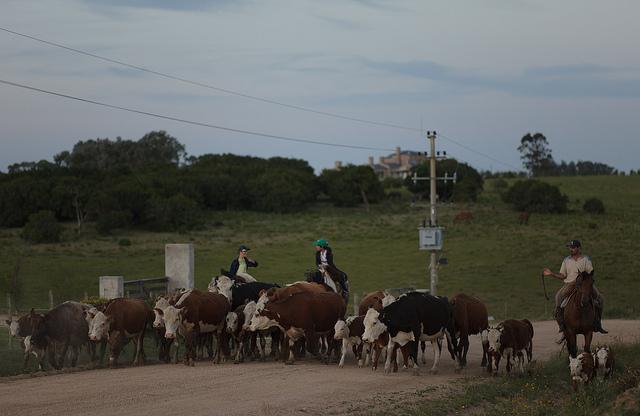Is there an electric line in this picture?
Keep it brief. Yes. Is it daylight?
Keep it brief. Yes. What are the people on horses doing?
Concise answer only. Riding. What is the color of the cows?
Short answer required. Brown and white. What animals are being shown?
Quick response, please. Cows. Which cow are these?
Quick response, please. Farm cows. Are there chickens in the picture?
Answer briefly. No. 